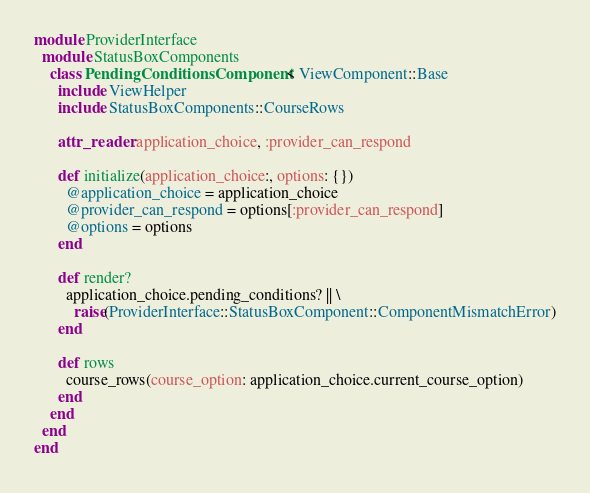Convert code to text. <code><loc_0><loc_0><loc_500><loc_500><_Ruby_>module ProviderInterface
  module StatusBoxComponents
    class PendingConditionsComponent < ViewComponent::Base
      include ViewHelper
      include StatusBoxComponents::CourseRows

      attr_reader :application_choice, :provider_can_respond

      def initialize(application_choice:, options: {})
        @application_choice = application_choice
        @provider_can_respond = options[:provider_can_respond]
        @options = options
      end

      def render?
        application_choice.pending_conditions? || \
          raise(ProviderInterface::StatusBoxComponent::ComponentMismatchError)
      end

      def rows
        course_rows(course_option: application_choice.current_course_option)
      end
    end
  end
end
</code> 